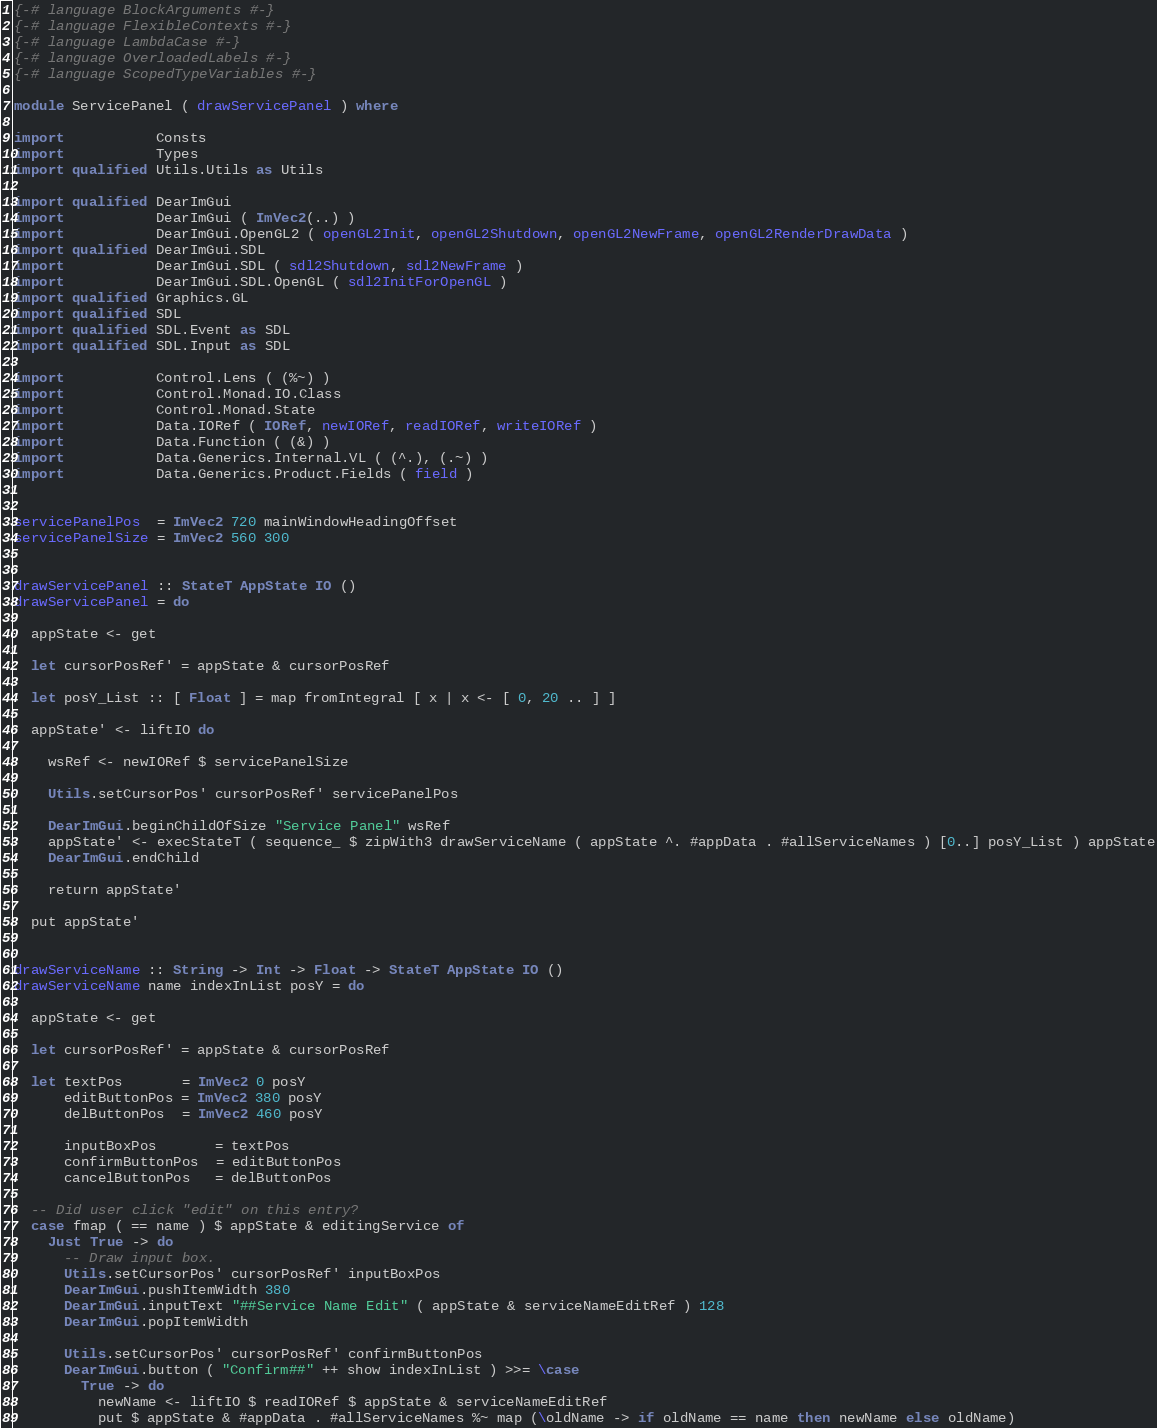Convert code to text. <code><loc_0><loc_0><loc_500><loc_500><_Haskell_>{-# language BlockArguments #-}
{-# language FlexibleContexts #-}
{-# language LambdaCase #-}
{-# language OverloadedLabels #-}
{-# language ScopedTypeVariables #-}

module ServicePanel ( drawServicePanel ) where

import           Consts
import           Types
import qualified Utils.Utils as Utils

import qualified DearImGui
import           DearImGui ( ImVec2(..) )
import           DearImGui.OpenGL2 ( openGL2Init, openGL2Shutdown, openGL2NewFrame, openGL2RenderDrawData )
import qualified DearImGui.SDL
import           DearImGui.SDL ( sdl2Shutdown, sdl2NewFrame )
import           DearImGui.SDL.OpenGL ( sdl2InitForOpenGL )
import qualified Graphics.GL
import qualified SDL
import qualified SDL.Event as SDL
import qualified SDL.Input as SDL

import           Control.Lens ( (%~) )
import           Control.Monad.IO.Class
import           Control.Monad.State
import           Data.IORef ( IORef, newIORef, readIORef, writeIORef )
import           Data.Function ( (&) )
import           Data.Generics.Internal.VL ( (^.), (.~) )
import           Data.Generics.Product.Fields ( field )


servicePanelPos  = ImVec2 720 mainWindowHeadingOffset
servicePanelSize = ImVec2 560 300


drawServicePanel :: StateT AppState IO ()
drawServicePanel = do

  appState <- get

  let cursorPosRef' = appState & cursorPosRef

  let posY_List :: [ Float ] = map fromIntegral [ x | x <- [ 0, 20 .. ] ]

  appState' <- liftIO do

    wsRef <- newIORef $ servicePanelSize

    Utils.setCursorPos' cursorPosRef' servicePanelPos

    DearImGui.beginChildOfSize "Service Panel" wsRef
    appState' <- execStateT ( sequence_ $ zipWith3 drawServiceName ( appState ^. #appData . #allServiceNames ) [0..] posY_List ) appState
    DearImGui.endChild

    return appState'

  put appState'


drawServiceName :: String -> Int -> Float -> StateT AppState IO ()
drawServiceName name indexInList posY = do

  appState <- get

  let cursorPosRef' = appState & cursorPosRef

  let textPos       = ImVec2 0 posY
      editButtonPos = ImVec2 380 posY
      delButtonPos  = ImVec2 460 posY

      inputBoxPos       = textPos
      confirmButtonPos  = editButtonPos
      cancelButtonPos   = delButtonPos

  -- Did user click "edit" on this entry?
  case fmap ( == name ) $ appState & editingService of
    Just True -> do
      -- Draw input box.
      Utils.setCursorPos' cursorPosRef' inputBoxPos
      DearImGui.pushItemWidth 380
      DearImGui.inputText "##Service Name Edit" ( appState & serviceNameEditRef ) 128
      DearImGui.popItemWidth

      Utils.setCursorPos' cursorPosRef' confirmButtonPos
      DearImGui.button ( "Confirm##" ++ show indexInList ) >>= \case
        True -> do
          newName <- liftIO $ readIORef $ appState & serviceNameEditRef
          put $ appState & #appData . #allServiceNames %~ map (\oldName -> if oldName == name then newName else oldName)</code> 